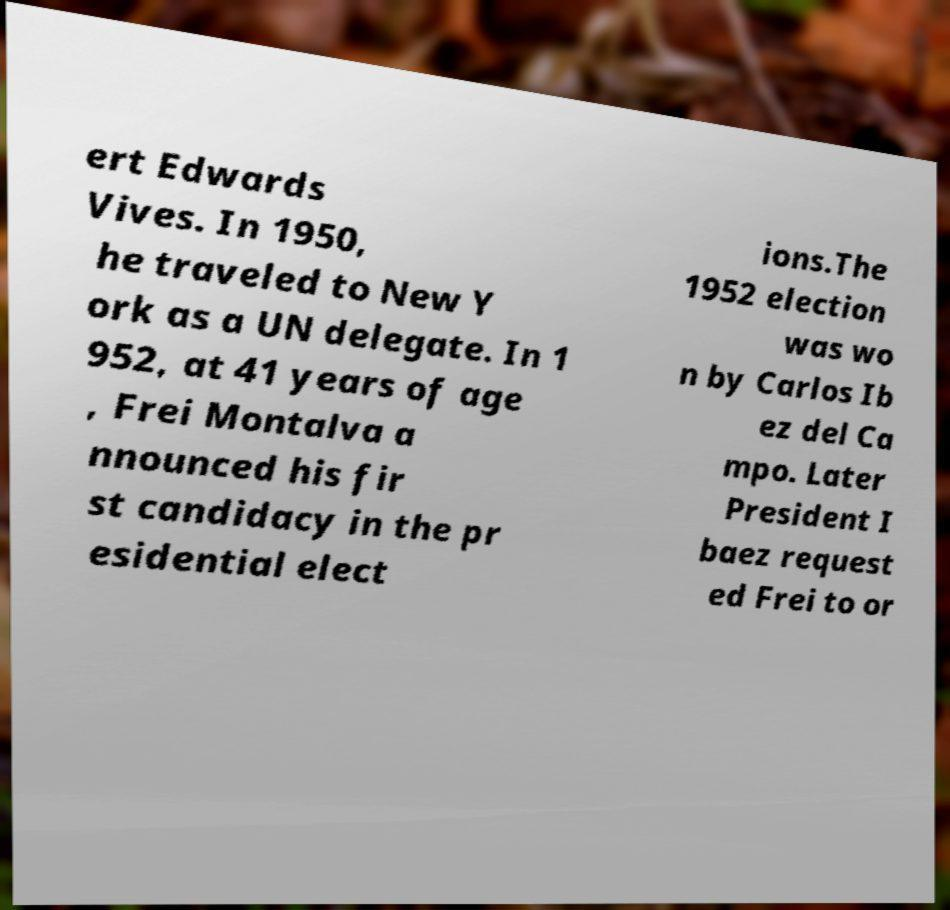Can you accurately transcribe the text from the provided image for me? ert Edwards Vives. In 1950, he traveled to New Y ork as a UN delegate. In 1 952, at 41 years of age , Frei Montalva a nnounced his fir st candidacy in the pr esidential elect ions.The 1952 election was wo n by Carlos Ib ez del Ca mpo. Later President I baez request ed Frei to or 